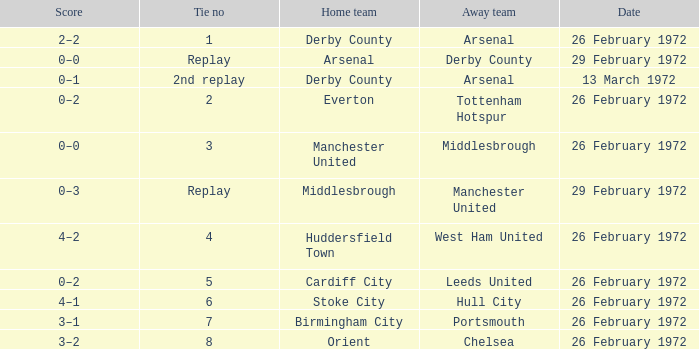Which Tie is from birmingham city? 7.0. 